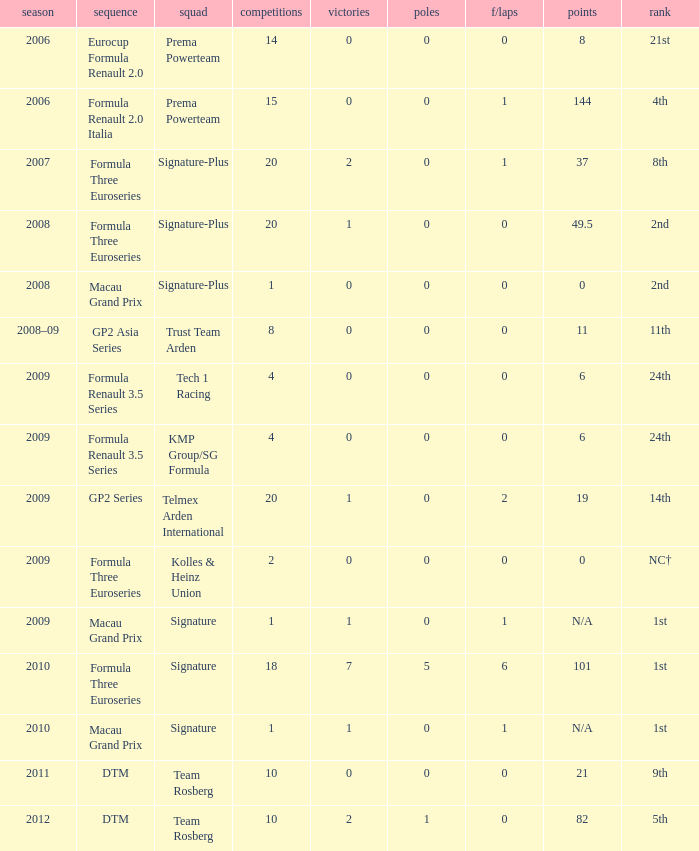Which series has 11 points? GP2 Asia Series. Parse the table in full. {'header': ['season', 'sequence', 'squad', 'competitions', 'victories', 'poles', 'f/laps', 'points', 'rank'], 'rows': [['2006', 'Eurocup Formula Renault 2.0', 'Prema Powerteam', '14', '0', '0', '0', '8', '21st'], ['2006', 'Formula Renault 2.0 Italia', 'Prema Powerteam', '15', '0', '0', '1', '144', '4th'], ['2007', 'Formula Three Euroseries', 'Signature-Plus', '20', '2', '0', '1', '37', '8th'], ['2008', 'Formula Three Euroseries', 'Signature-Plus', '20', '1', '0', '0', '49.5', '2nd'], ['2008', 'Macau Grand Prix', 'Signature-Plus', '1', '0', '0', '0', '0', '2nd'], ['2008–09', 'GP2 Asia Series', 'Trust Team Arden', '8', '0', '0', '0', '11', '11th'], ['2009', 'Formula Renault 3.5 Series', 'Tech 1 Racing', '4', '0', '0', '0', '6', '24th'], ['2009', 'Formula Renault 3.5 Series', 'KMP Group/SG Formula', '4', '0', '0', '0', '6', '24th'], ['2009', 'GP2 Series', 'Telmex Arden International', '20', '1', '0', '2', '19', '14th'], ['2009', 'Formula Three Euroseries', 'Kolles & Heinz Union', '2', '0', '0', '0', '0', 'NC†'], ['2009', 'Macau Grand Prix', 'Signature', '1', '1', '0', '1', 'N/A', '1st'], ['2010', 'Formula Three Euroseries', 'Signature', '18', '7', '5', '6', '101', '1st'], ['2010', 'Macau Grand Prix', 'Signature', '1', '1', '0', '1', 'N/A', '1st'], ['2011', 'DTM', 'Team Rosberg', '10', '0', '0', '0', '21', '9th'], ['2012', 'DTM', 'Team Rosberg', '10', '2', '1', '0', '82', '5th']]} 